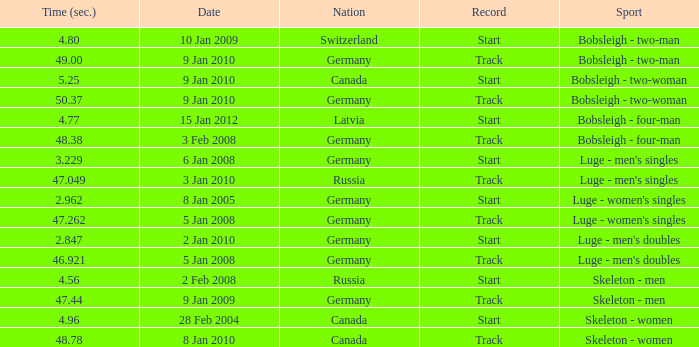In which country did they complete the event in 47.049 seconds? Russia. 